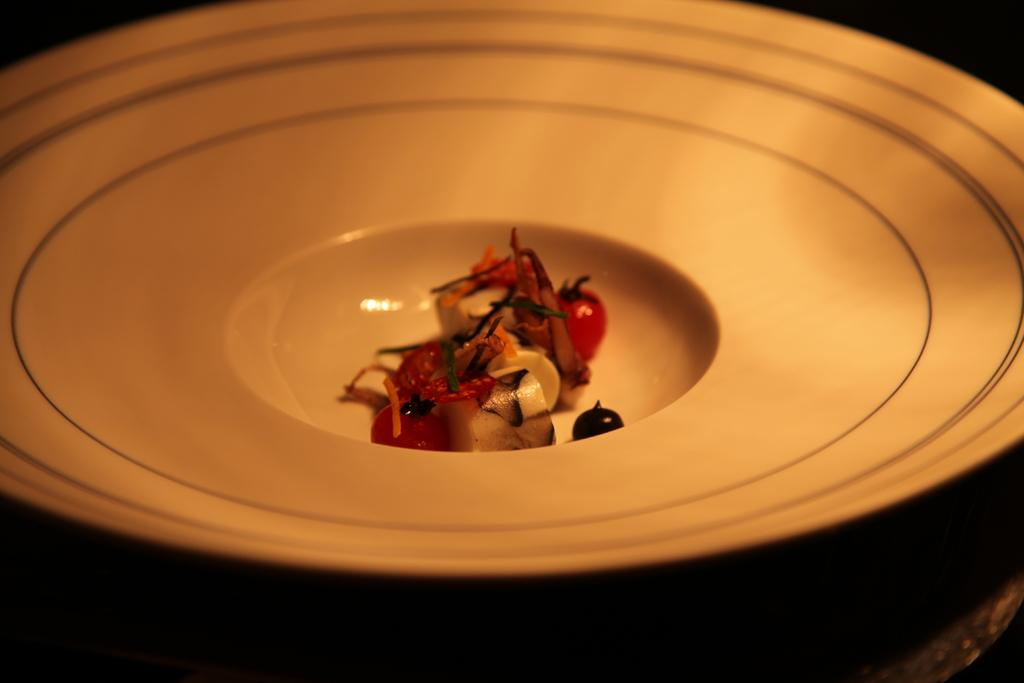What piece of furniture is present in the image? There is a table in the image. What is placed on the table? There is a plate with a food item on the table. Is there a dog at the party in the image? There is no party or dog present in the image; it only shows a table with a plate and a food item. 